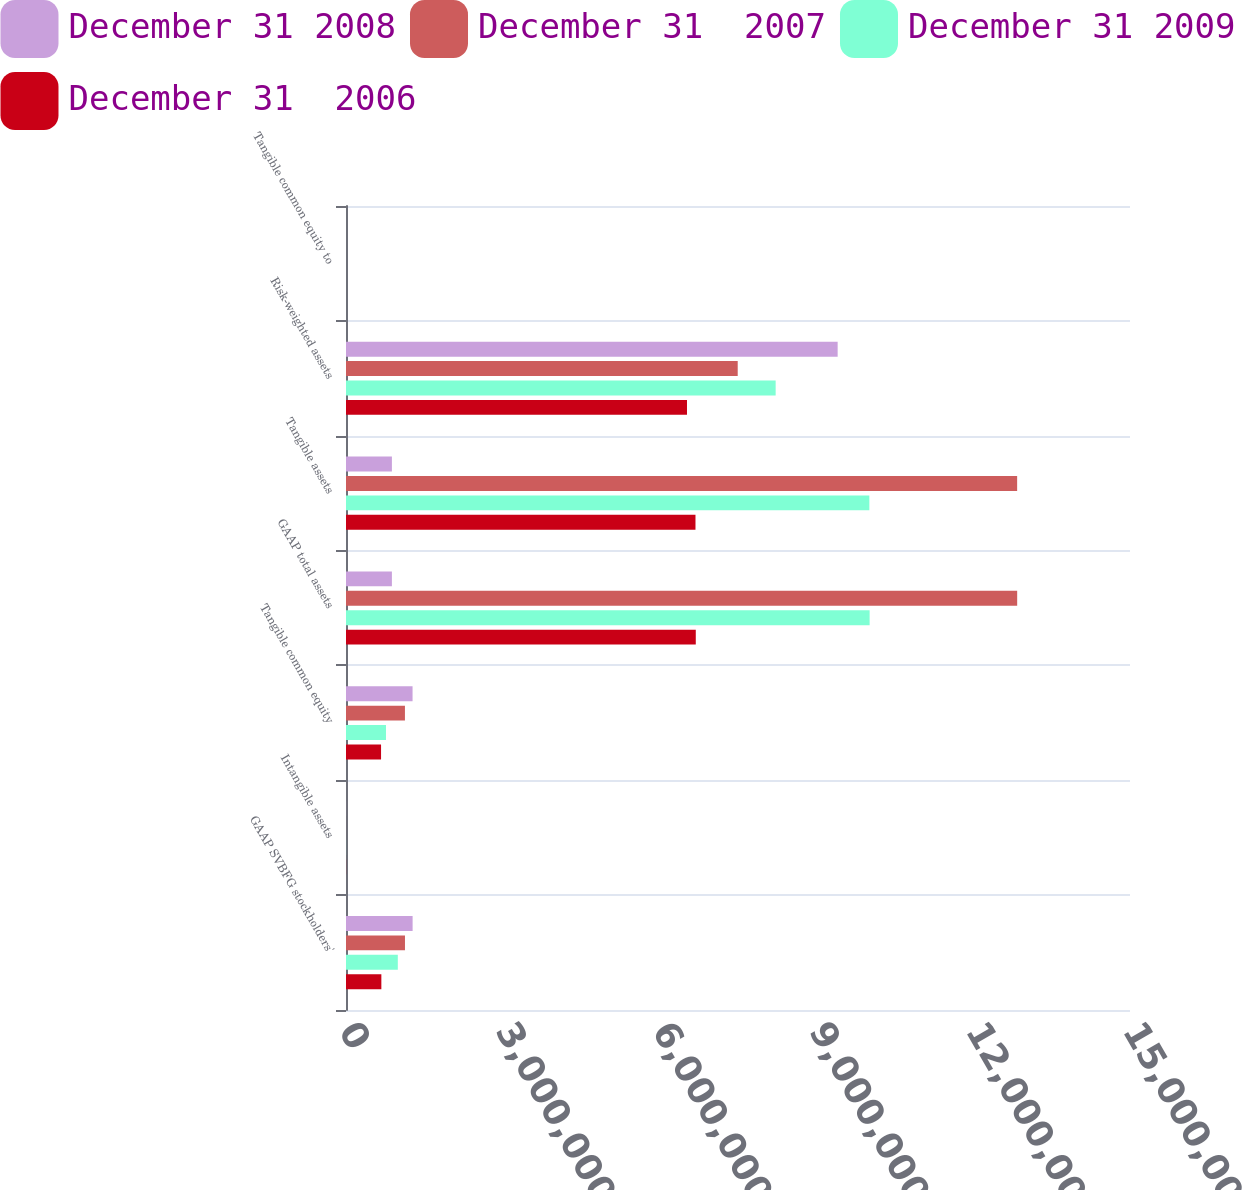Convert chart to OTSL. <chart><loc_0><loc_0><loc_500><loc_500><stacked_bar_chart><ecel><fcel>GAAP SVBFG stockholders'<fcel>Intangible assets<fcel>Tangible common equity<fcel>GAAP total assets<fcel>Tangible assets<fcel>Risk-weighted assets<fcel>Tangible common equity to<nl><fcel>December 31 2008<fcel>1.27435e+06<fcel>847<fcel>1.2735e+06<fcel>878174<fcel>878174<fcel>9.40668e+06<fcel>13.54<nl><fcel>December 31  2007<fcel>1.12834e+06<fcel>665<fcel>1.12768e+06<fcel>1.28414e+07<fcel>1.28407e+07<fcel>7.4945e+06<fcel>15.05<nl><fcel>December 31 2009<fcel>991356<fcel>1087<fcel>764992<fcel>1.00183e+07<fcel>1.00131e+07<fcel>8.22045e+06<fcel>9.31<nl><fcel>December 31  2006<fcel>676369<fcel>1632<fcel>670645<fcel>6.69217e+06<fcel>6.68645e+06<fcel>6.52402e+06<fcel>10.28<nl></chart> 